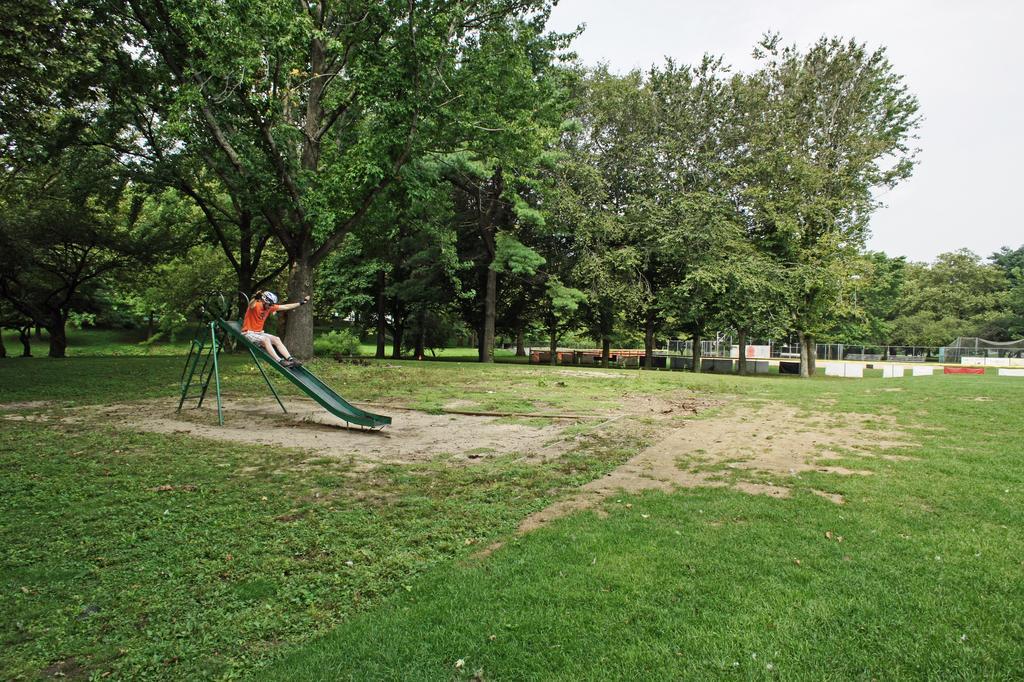Could you give a brief overview of what you see in this image? In this picture I see the grass and in the middle of this picture I see a slide on which there is a person and I see number of trees. In the background I see the sky. 